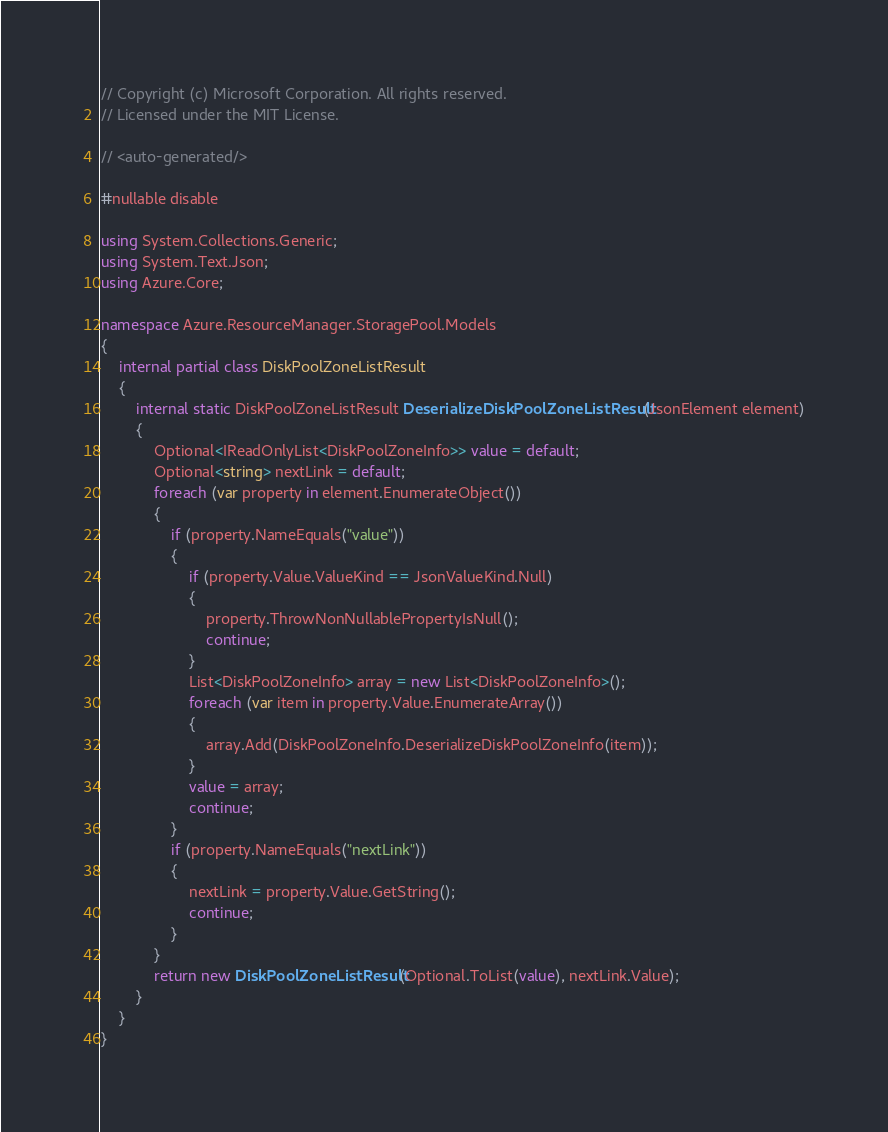Convert code to text. <code><loc_0><loc_0><loc_500><loc_500><_C#_>// Copyright (c) Microsoft Corporation. All rights reserved.
// Licensed under the MIT License.

// <auto-generated/>

#nullable disable

using System.Collections.Generic;
using System.Text.Json;
using Azure.Core;

namespace Azure.ResourceManager.StoragePool.Models
{
    internal partial class DiskPoolZoneListResult
    {
        internal static DiskPoolZoneListResult DeserializeDiskPoolZoneListResult(JsonElement element)
        {
            Optional<IReadOnlyList<DiskPoolZoneInfo>> value = default;
            Optional<string> nextLink = default;
            foreach (var property in element.EnumerateObject())
            {
                if (property.NameEquals("value"))
                {
                    if (property.Value.ValueKind == JsonValueKind.Null)
                    {
                        property.ThrowNonNullablePropertyIsNull();
                        continue;
                    }
                    List<DiskPoolZoneInfo> array = new List<DiskPoolZoneInfo>();
                    foreach (var item in property.Value.EnumerateArray())
                    {
                        array.Add(DiskPoolZoneInfo.DeserializeDiskPoolZoneInfo(item));
                    }
                    value = array;
                    continue;
                }
                if (property.NameEquals("nextLink"))
                {
                    nextLink = property.Value.GetString();
                    continue;
                }
            }
            return new DiskPoolZoneListResult(Optional.ToList(value), nextLink.Value);
        }
    }
}
</code> 